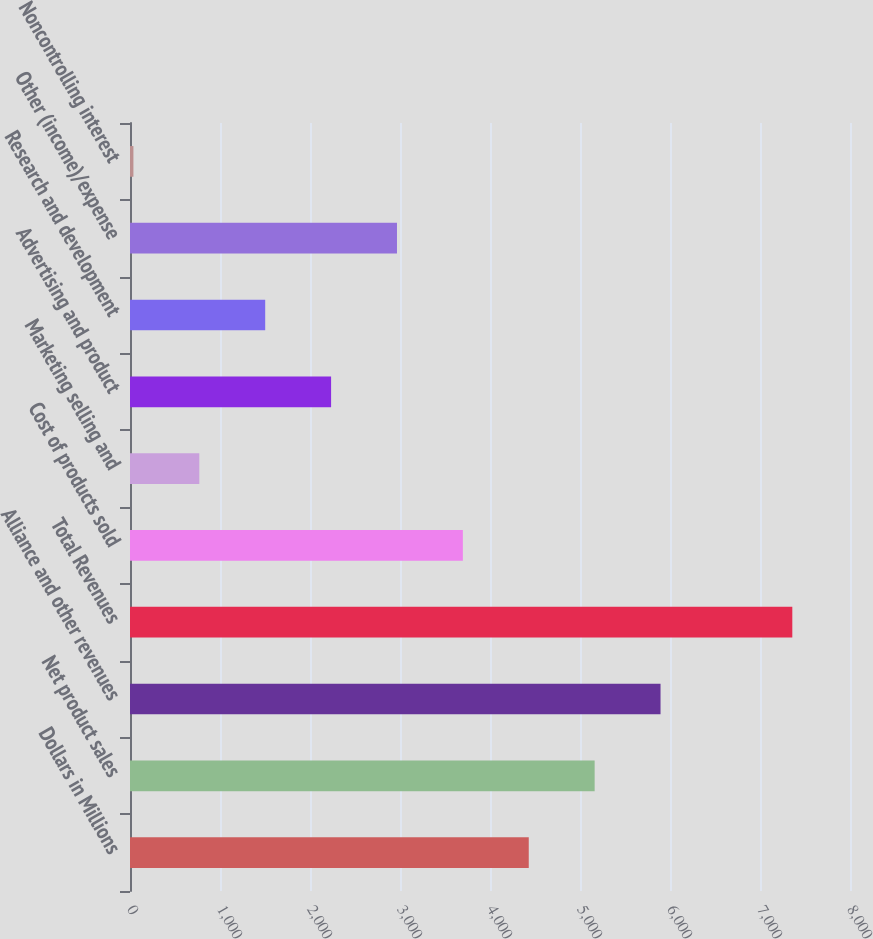Convert chart. <chart><loc_0><loc_0><loc_500><loc_500><bar_chart><fcel>Dollars in Millions<fcel>Net product sales<fcel>Alliance and other revenues<fcel>Total Revenues<fcel>Cost of products sold<fcel>Marketing selling and<fcel>Advertising and product<fcel>Research and development<fcel>Other (income)/expense<fcel>Noncontrolling interest<nl><fcel>4430.6<fcel>5162.7<fcel>5894.8<fcel>7359<fcel>3698.5<fcel>770.1<fcel>2234.3<fcel>1502.2<fcel>2966.4<fcel>38<nl></chart> 